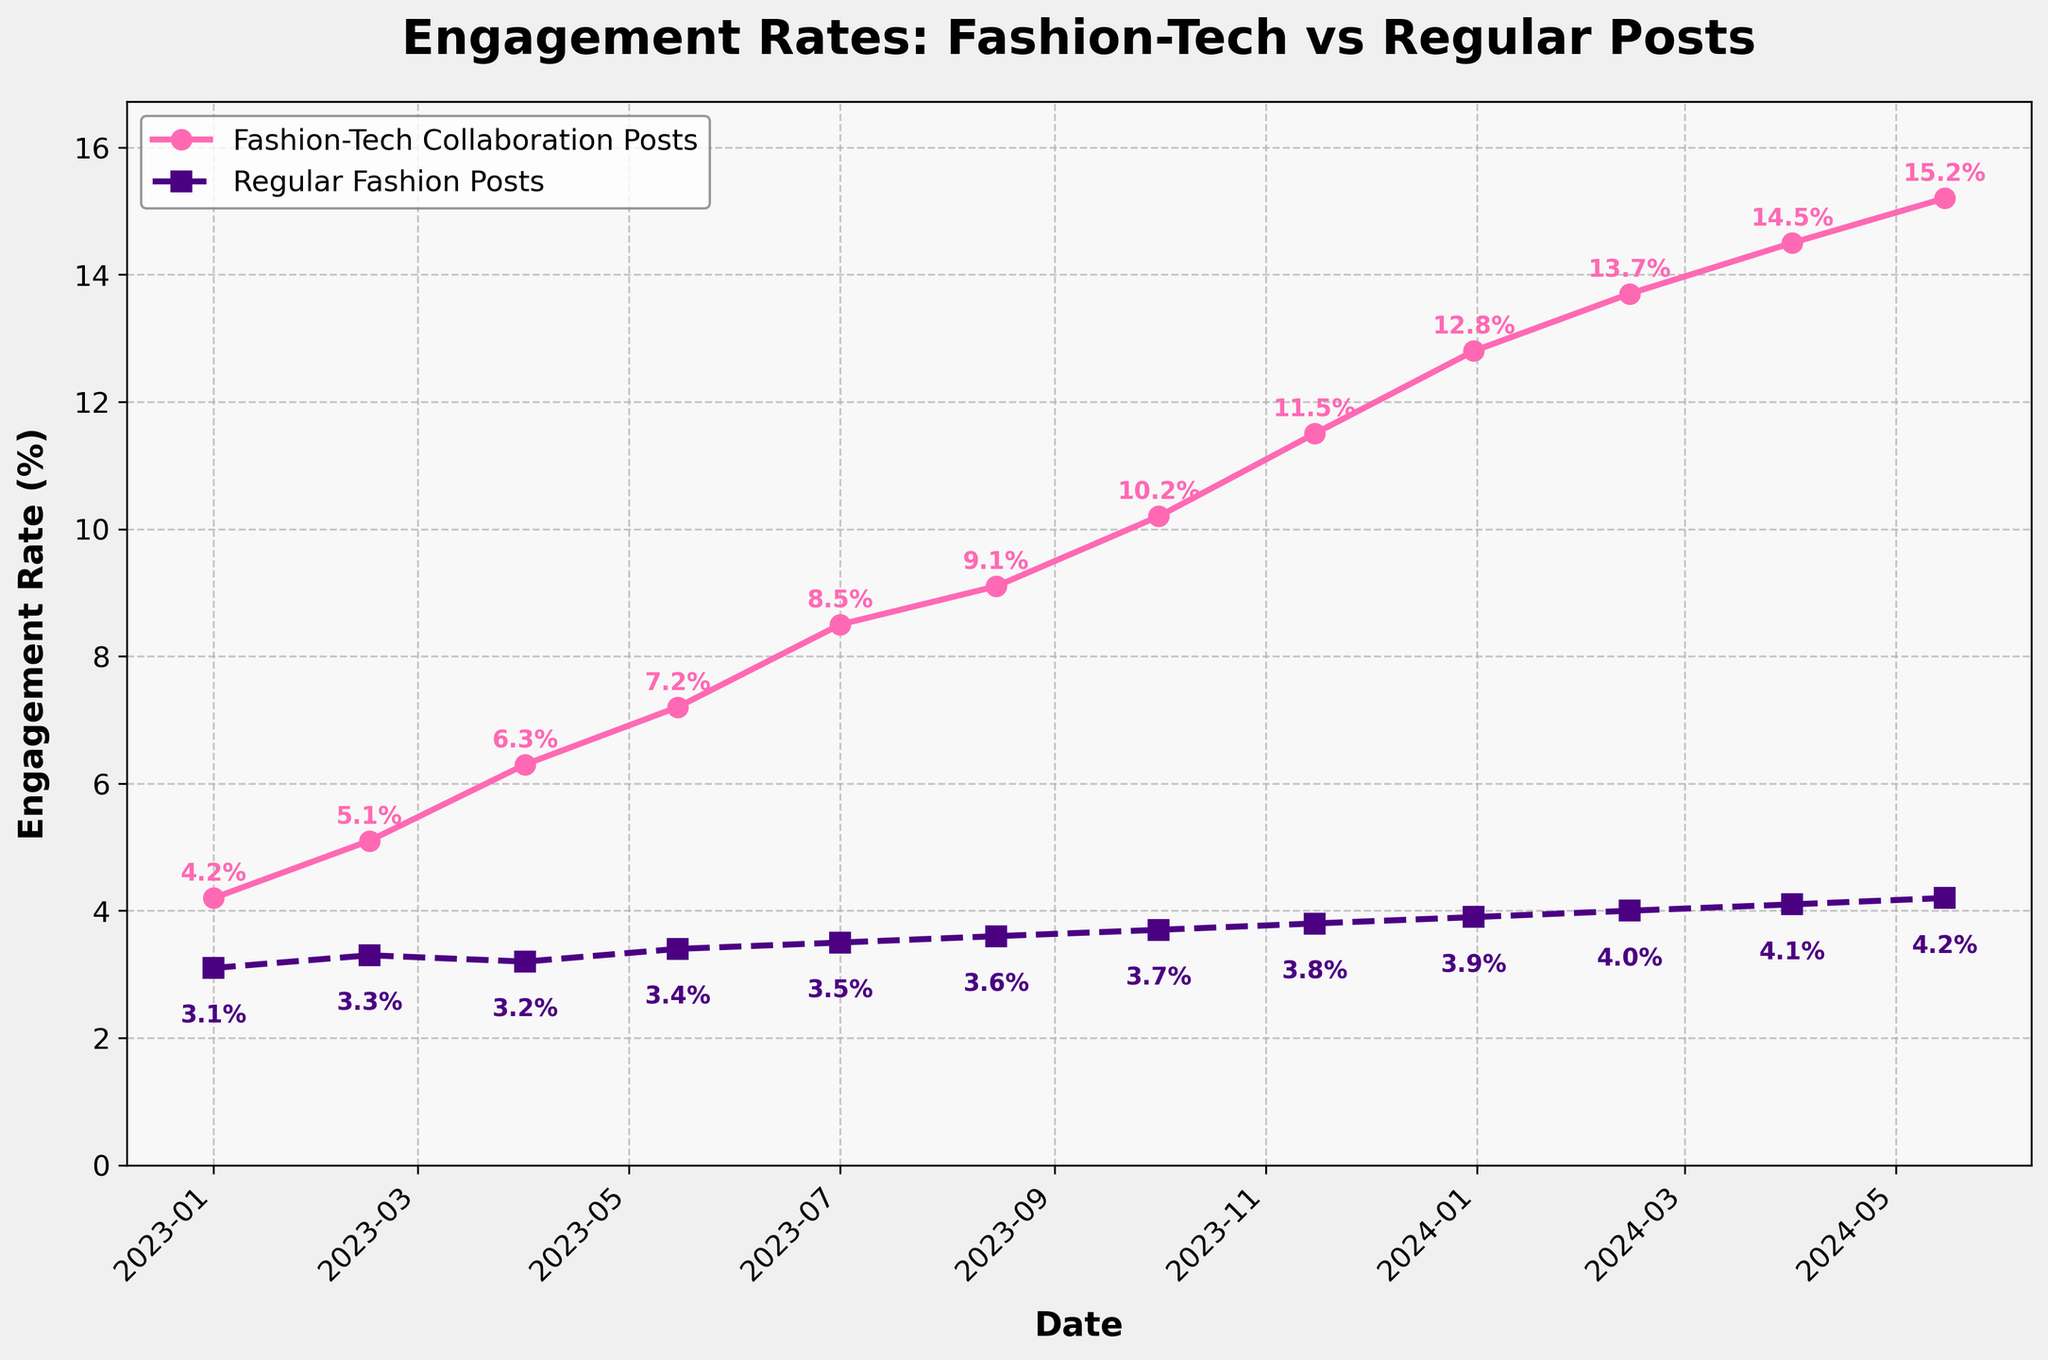What is the engagement rate for Fashion-Tech Collaboration Posts on 2024-04-01? Find the data point on the graph for 2024-04-01 and note the engagement rate for Fashion-Tech Collaboration Posts
Answer: 14.5% What is the difference in engagement rates between Fashion-Tech Collaboration Posts and Regular Fashion Posts on 2023-10-01? Find the engagement rates for both types of posts on 2023-10-01: Fashion-Tech Collaboration Posts are at 10.2%, and Regular Fashion Posts are at 3.7%. Subtract the Regular Fashion Posts rate from the Fashion-Tech Collaboration Posts rate: 10.2% - 3.7% = 6.5%
Answer: 6.5% Which type of post had a higher engagement rate on 2023-02-15, and by how much? Locate the engagement rates for both types of posts on 2023-02-15: Fashion-Tech Collaboration Posts at 5.1% and Regular Fashion Posts at 3.3%. Subtract the Regular Fashion Posts rate from the Fashion-Tech Collaboration Posts rate: 5.1% - 3.3% = 1.8%. Fashion-Tech Collaboration Posts had a higher rate
Answer: Fashion-Tech Collaboration Posts by 1.8% Between which two dates did the Fashion-Tech Collaboration Posts see the highest increase in engagement rate? Review the engagement rate increments between each pair of consecutive dates. Notice the highest increment from 2023-12-31 (12.8%) to 2024-02-14 (13.7%): increase = 13.7% - 12.8% = 0.9%
Answer: 2023-12-31 to 2024-02-14 What trend do you observe in the engagement rates for both types of posts over the entire period? Both engagement rates show an upward trend over time. Fashion-Tech Collaboration Posts increase significantly more steeply than Regular Fashion Posts
Answer: Upward trend for both, steeper for Fashion-Tech Collaboration Posts How much did the engagement rate for Regular Fashion Posts change from the start to the end of the period? Find the engagement rate for Regular Fashion Posts at the beginning (2023-01-01: 3.1%) and the end (2024-05-15: 4.2%). Calculate the difference: 4.2% - 3.1% = 1.1%
Answer: 1.1% What are the colors used to represent Fashion-Tech Collaboration Posts and Regular Fashion Posts in the plot? Observe the line colors on the plot, where Fashion-Tech Collaboration Posts are indicated by a pink line, and Regular Fashion Posts by an indigo line
Answer: Pink for Fashion-Tech, Indigo for Regular By how much did the engagement rate for Fashion-Tech Collaboration Posts surpass that of Regular Fashion Posts in percentage terms on 2024-05-15? Find the engagement rates on 2024-05-15 (15.2% for Fashion-Tech Collaboration Posts and 4.2% for Regular Fashion Posts). Calculate the difference as a percentage: (15.2% - 4.2%) = 11.0 percentage points
Answer: 11.0 percentage points 